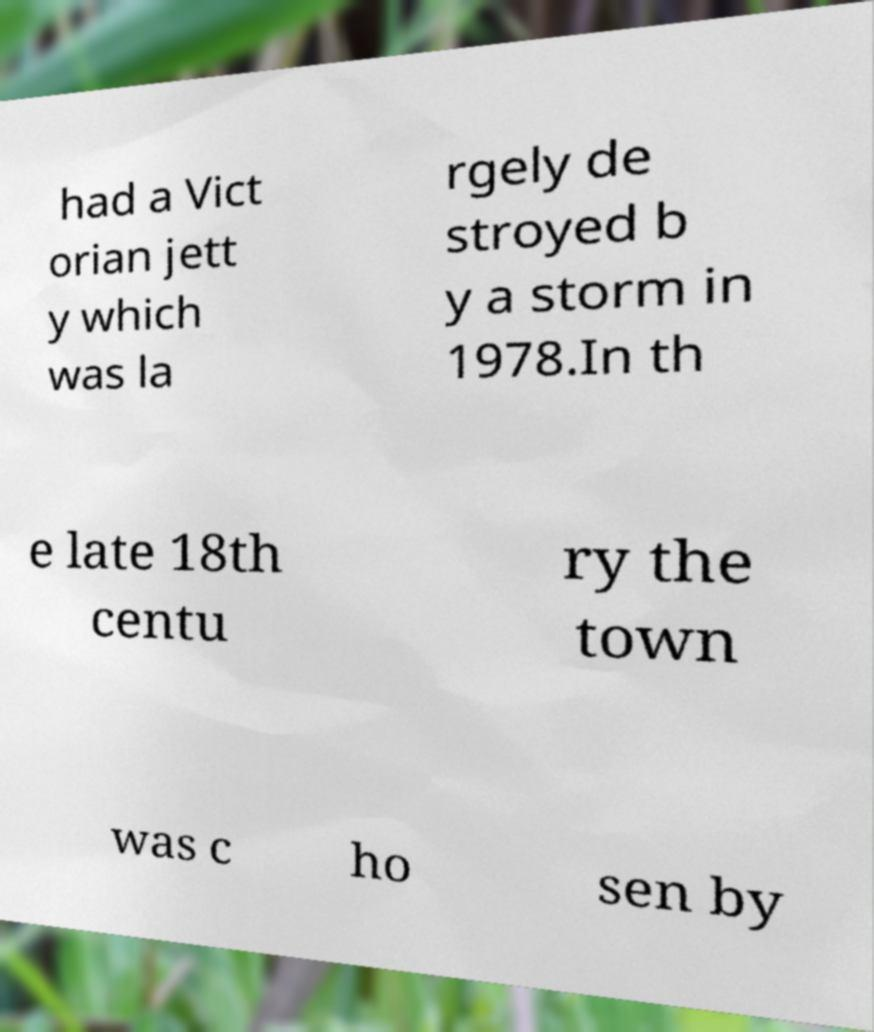What messages or text are displayed in this image? I need them in a readable, typed format. had a Vict orian jett y which was la rgely de stroyed b y a storm in 1978.In th e late 18th centu ry the town was c ho sen by 